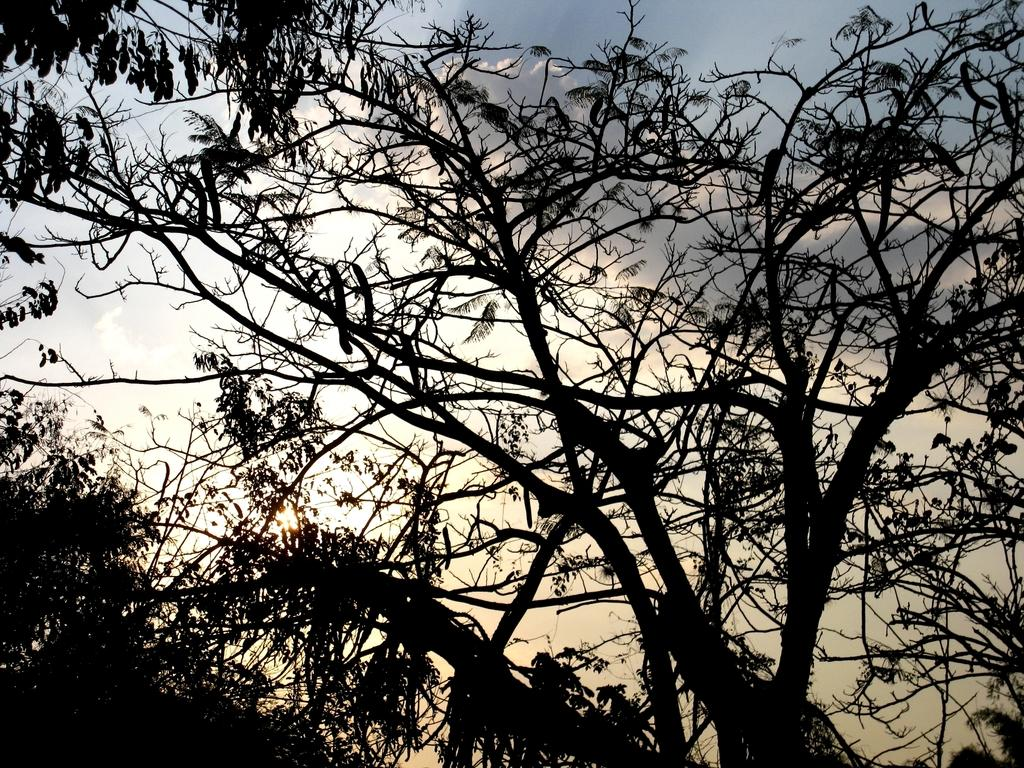What type of plant parts can be seen in the image? There are branches, stems, and leaves of trees in the image. What is visible in the background of the image? There is sky visible in the background of the image. What type of natural light is present in the image? There is sunlight in the image. How many yokes are hanging from the branches in the image? There are no yokes present in the image; it features branches, stems, and leaves of trees. What is the duration of the minute shown in the image? There is no specific minute or time duration depicted in the image, as it focuses on plant parts and the sky. 